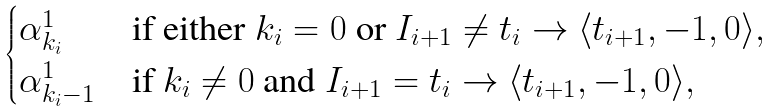<formula> <loc_0><loc_0><loc_500><loc_500>\begin{cases} \alpha ^ { 1 } _ { k _ { i } } & \text {if either} \ k _ { i } = 0 \ \text {or} \ I _ { i + 1 } \ne t _ { i } \to \langle t _ { i + 1 } , - 1 , 0 \rangle , \\ \alpha ^ { 1 } _ { k _ { i } - 1 } & \text {if} \ k _ { i } \ne 0 \ \text {and} \ I _ { i + 1 } = t _ { i } \to \langle t _ { i + 1 } , - 1 , 0 \rangle , \end{cases}</formula> 